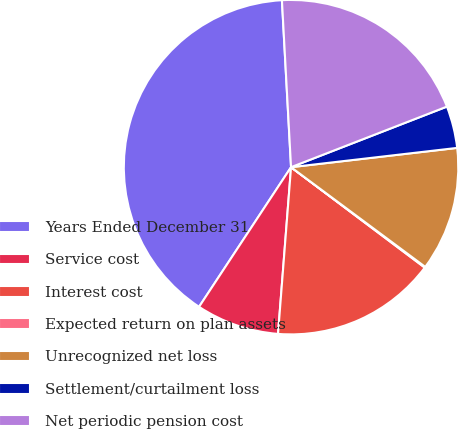<chart> <loc_0><loc_0><loc_500><loc_500><pie_chart><fcel>Years Ended December 31<fcel>Service cost<fcel>Interest cost<fcel>Expected return on plan assets<fcel>Unrecognized net loss<fcel>Settlement/curtailment loss<fcel>Net periodic pension cost<nl><fcel>39.86%<fcel>8.03%<fcel>15.99%<fcel>0.08%<fcel>12.01%<fcel>4.06%<fcel>19.97%<nl></chart> 